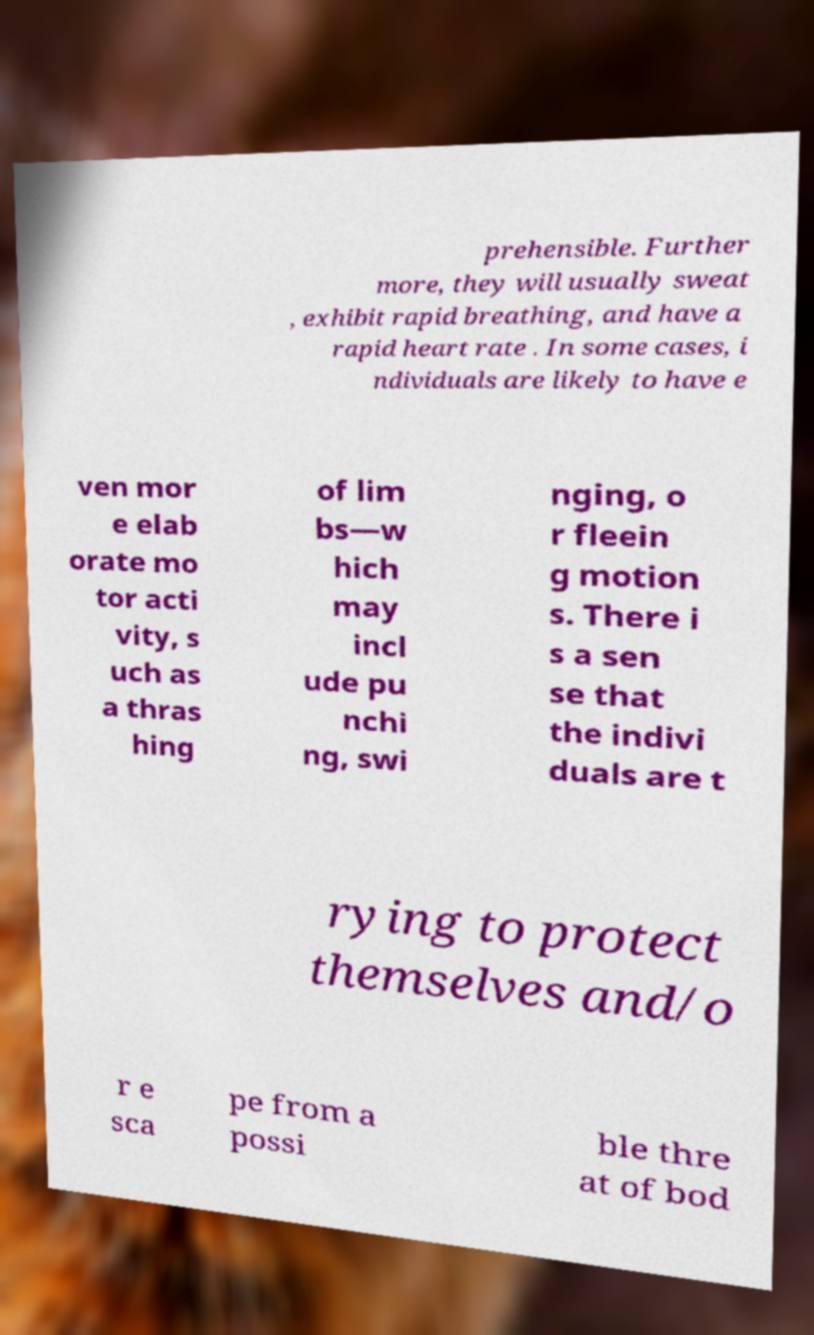Please identify and transcribe the text found in this image. prehensible. Further more, they will usually sweat , exhibit rapid breathing, and have a rapid heart rate . In some cases, i ndividuals are likely to have e ven mor e elab orate mo tor acti vity, s uch as a thras hing of lim bs—w hich may incl ude pu nchi ng, swi nging, o r fleein g motion s. There i s a sen se that the indivi duals are t rying to protect themselves and/o r e sca pe from a possi ble thre at of bod 